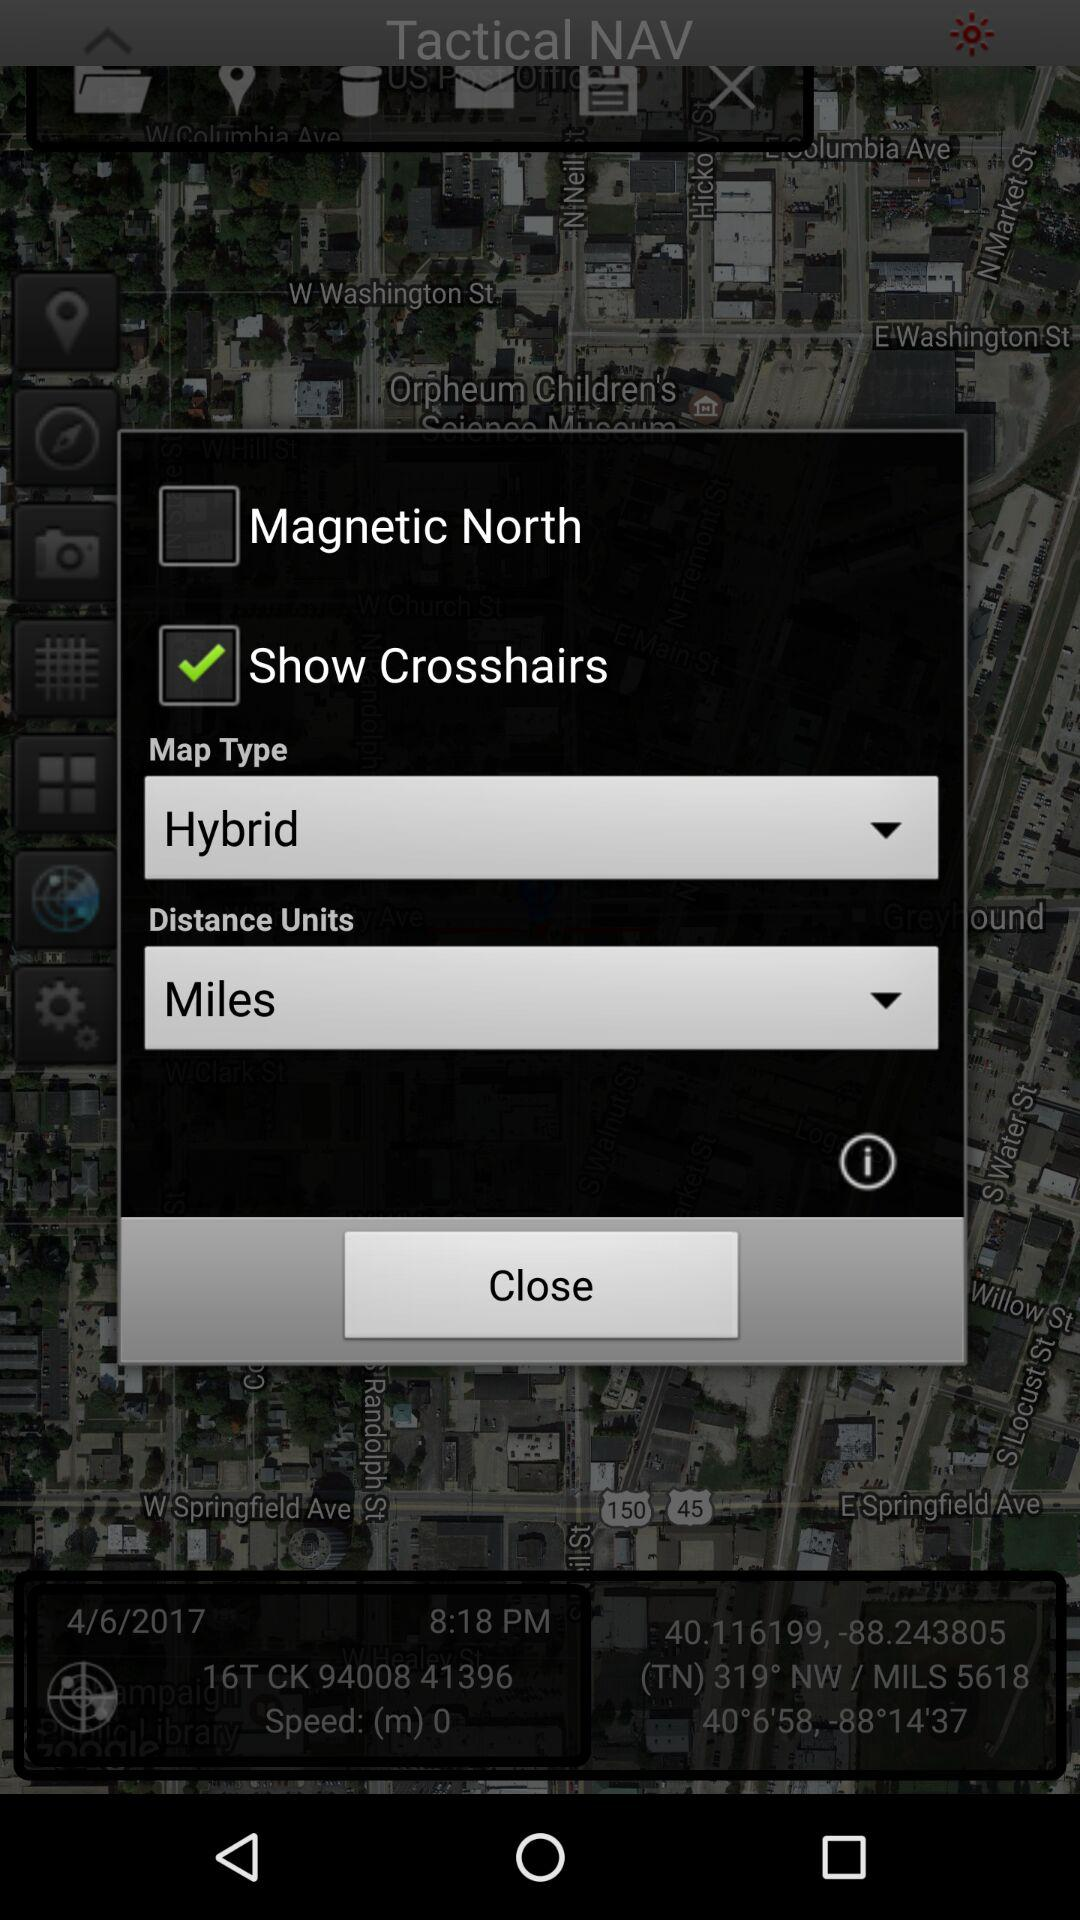What is the current status of the "Magnetic North" setting? The current status of the "Magnetic North" setting is "off". 